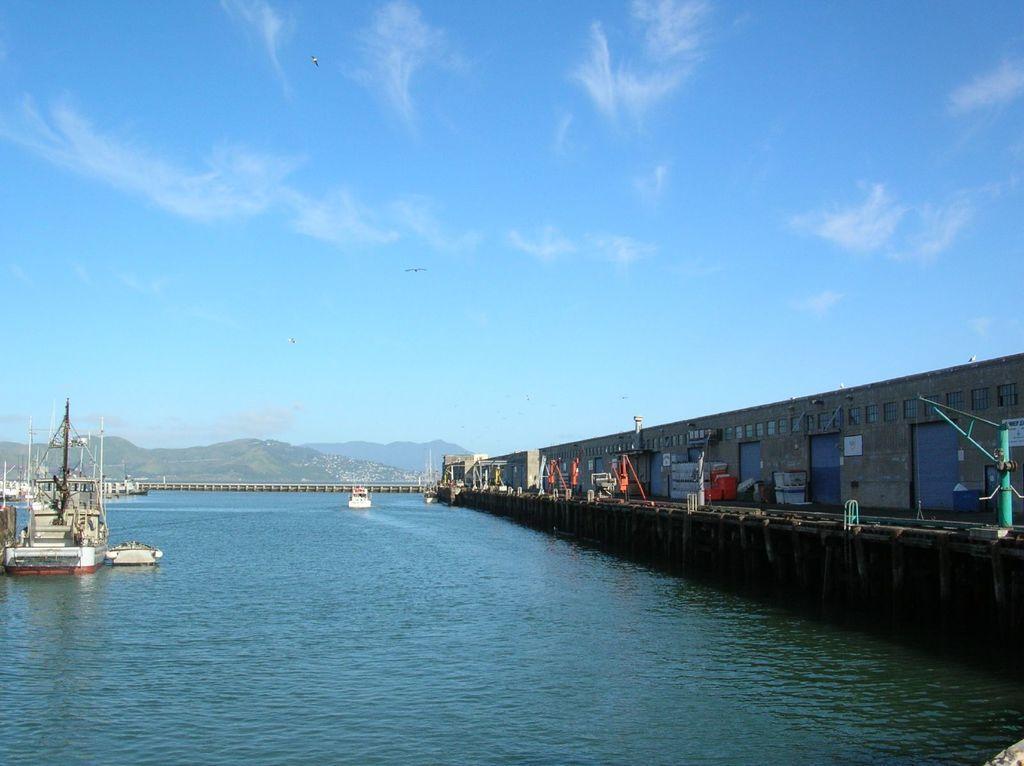Please provide a concise description of this image. In the image there is a water surface and beside that there is a bridge and there is a ship floating on the water surface, in the background there are mountains. 